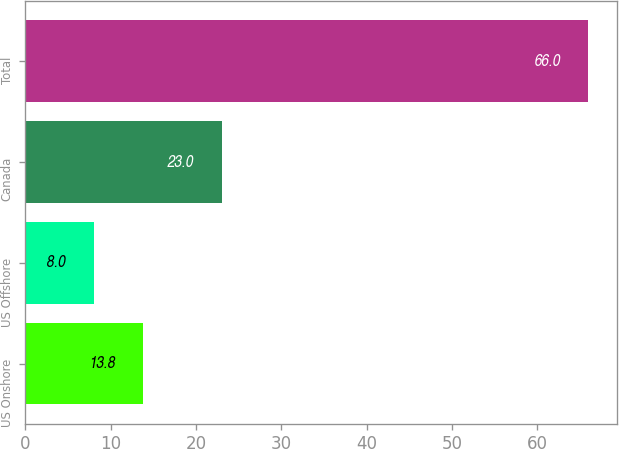<chart> <loc_0><loc_0><loc_500><loc_500><bar_chart><fcel>US Onshore<fcel>US Offshore<fcel>Canada<fcel>Total<nl><fcel>13.8<fcel>8<fcel>23<fcel>66<nl></chart> 